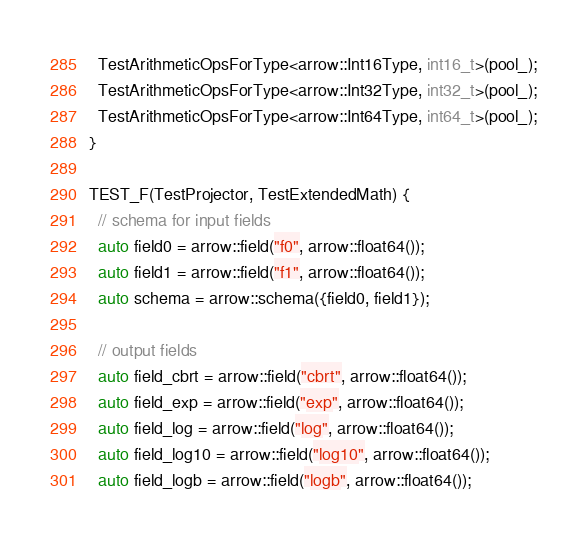<code> <loc_0><loc_0><loc_500><loc_500><_C++_>  TestArithmeticOpsForType<arrow::Int16Type, int16_t>(pool_);
  TestArithmeticOpsForType<arrow::Int32Type, int32_t>(pool_);
  TestArithmeticOpsForType<arrow::Int64Type, int64_t>(pool_);
}

TEST_F(TestProjector, TestExtendedMath) {
  // schema for input fields
  auto field0 = arrow::field("f0", arrow::float64());
  auto field1 = arrow::field("f1", arrow::float64());
  auto schema = arrow::schema({field0, field1});

  // output fields
  auto field_cbrt = arrow::field("cbrt", arrow::float64());
  auto field_exp = arrow::field("exp", arrow::float64());
  auto field_log = arrow::field("log", arrow::float64());
  auto field_log10 = arrow::field("log10", arrow::float64());
  auto field_logb = arrow::field("logb", arrow::float64());</code> 